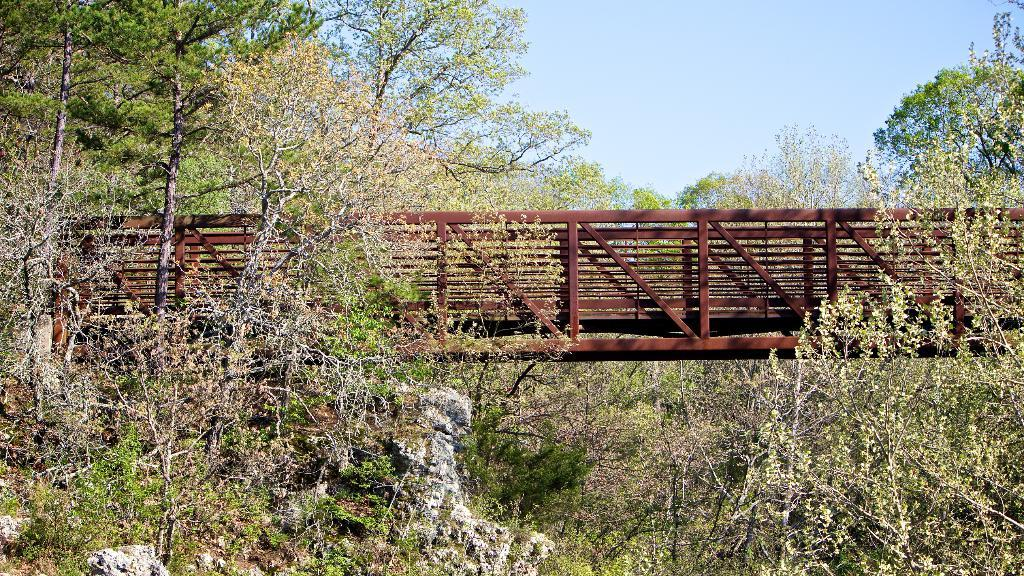What is the main structure in the middle of the picture? There is a brown color bridge in the middle of the picture. What can be seen in the background of the picture? There are trees and the sky visible in the background of the picture. How many hands are visible holding the bridge in the image? There are no hands visible holding the bridge in the image. What type of mass is present in the background of the image? There is no mass present in the image; it features a bridge, trees, and the sky. 